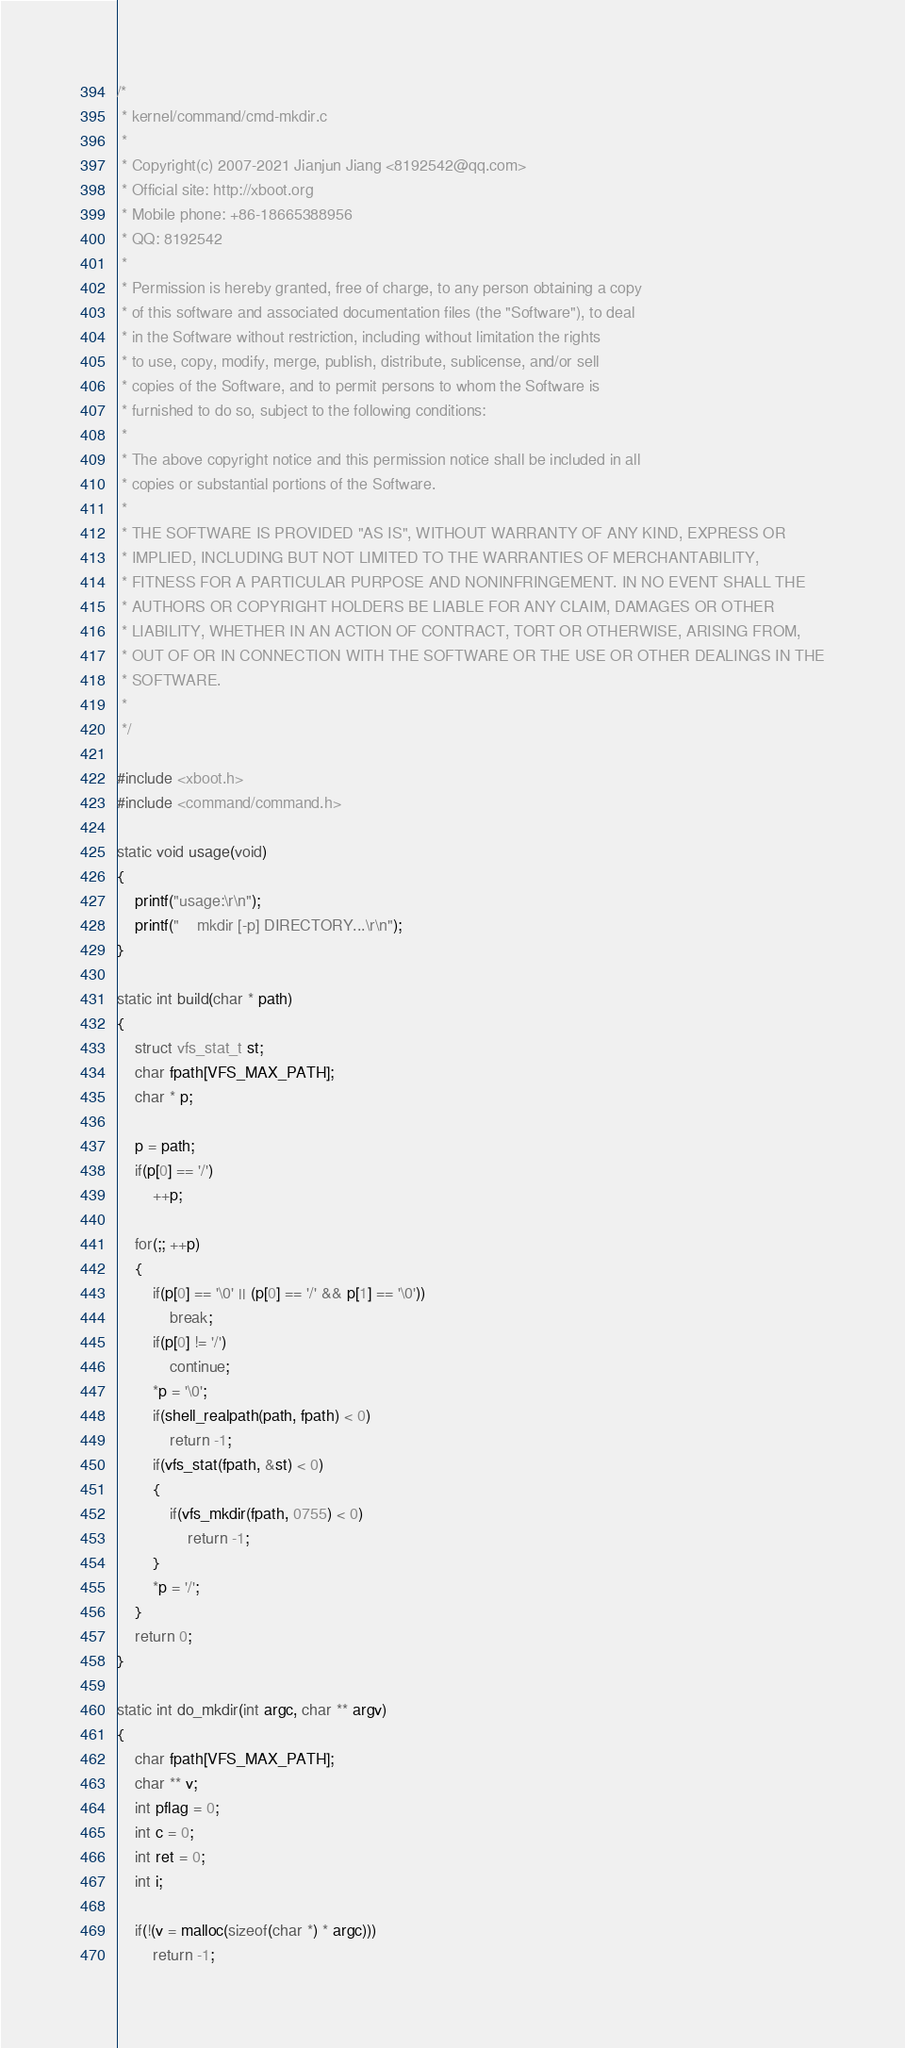<code> <loc_0><loc_0><loc_500><loc_500><_C_>/*
 * kernel/command/cmd-mkdir.c
 *
 * Copyright(c) 2007-2021 Jianjun Jiang <8192542@qq.com>
 * Official site: http://xboot.org
 * Mobile phone: +86-18665388956
 * QQ: 8192542
 *
 * Permission is hereby granted, free of charge, to any person obtaining a copy
 * of this software and associated documentation files (the "Software"), to deal
 * in the Software without restriction, including without limitation the rights
 * to use, copy, modify, merge, publish, distribute, sublicense, and/or sell
 * copies of the Software, and to permit persons to whom the Software is
 * furnished to do so, subject to the following conditions:
 *
 * The above copyright notice and this permission notice shall be included in all
 * copies or substantial portions of the Software.
 *
 * THE SOFTWARE IS PROVIDED "AS IS", WITHOUT WARRANTY OF ANY KIND, EXPRESS OR
 * IMPLIED, INCLUDING BUT NOT LIMITED TO THE WARRANTIES OF MERCHANTABILITY,
 * FITNESS FOR A PARTICULAR PURPOSE AND NONINFRINGEMENT. IN NO EVENT SHALL THE
 * AUTHORS OR COPYRIGHT HOLDERS BE LIABLE FOR ANY CLAIM, DAMAGES OR OTHER
 * LIABILITY, WHETHER IN AN ACTION OF CONTRACT, TORT OR OTHERWISE, ARISING FROM,
 * OUT OF OR IN CONNECTION WITH THE SOFTWARE OR THE USE OR OTHER DEALINGS IN THE
 * SOFTWARE.
 *
 */

#include <xboot.h>
#include <command/command.h>

static void usage(void)
{
	printf("usage:\r\n");
	printf("    mkdir [-p] DIRECTORY...\r\n");
}

static int build(char * path)
{
	struct vfs_stat_t st;
	char fpath[VFS_MAX_PATH];
	char * p;

	p = path;
	if(p[0] == '/')
		++p;

	for(;; ++p)
	{
		if(p[0] == '\0' || (p[0] == '/' && p[1] == '\0'))
			break;
		if(p[0] != '/')
			continue;
		*p = '\0';
		if(shell_realpath(path, fpath) < 0)
			return -1;
		if(vfs_stat(fpath, &st) < 0)
		{
			if(vfs_mkdir(fpath, 0755) < 0)
				return -1;
		}
		*p = '/';
	}
	return 0;
}

static int do_mkdir(int argc, char ** argv)
{
	char fpath[VFS_MAX_PATH];
	char ** v;
	int pflag = 0;
	int c = 0;
	int ret = 0;
	int i;

	if(!(v = malloc(sizeof(char *) * argc)))
		return -1;
</code> 